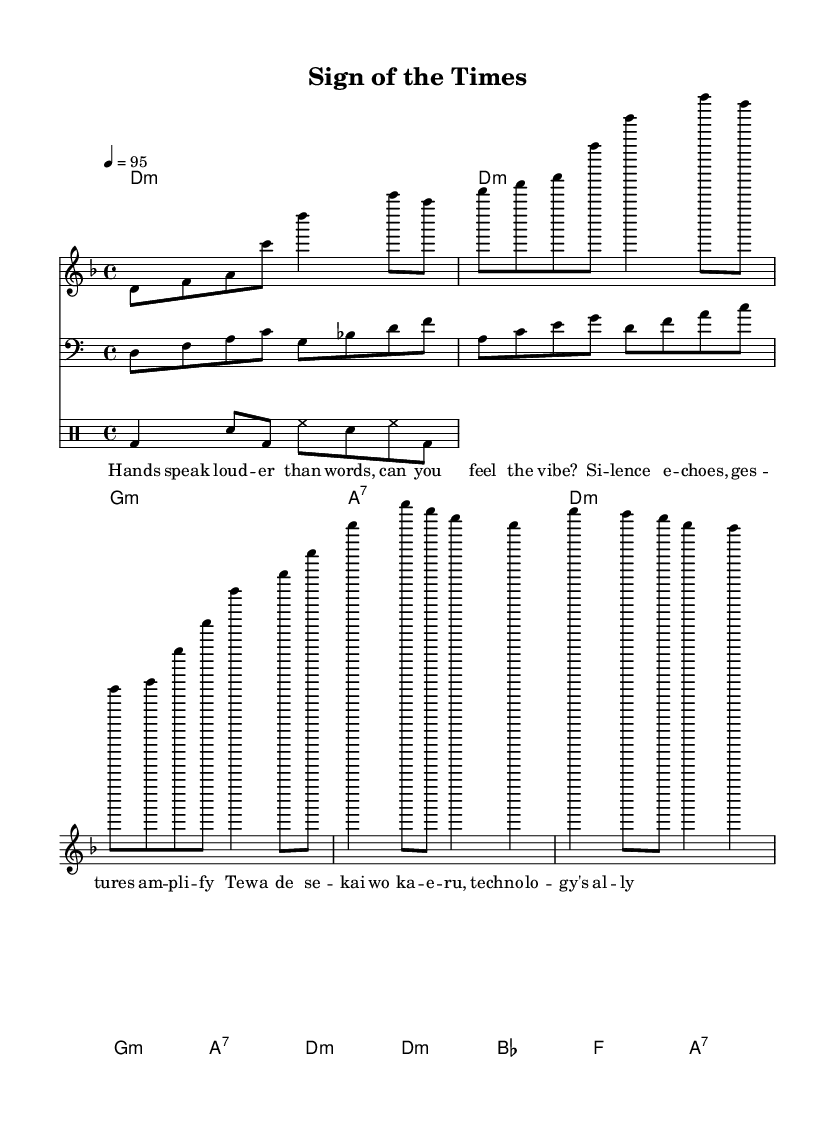What is the key signature of this music? The key signature is indicated as D minor, which typically includes one flat. In the staff, we see a flat sign associated with the D key.
Answer: D minor What is the time signature of this piece? The time signature is indicated at the beginning as 4/4, which means there are four beats in each measure and each beat is a quarter note. This can be identified from the notational symbols at the start of the sheet music.
Answer: 4/4 What is the tempo marking for this music? The tempo marking indicates that the piece should be played at a speed of 95 beats per minute, as shown in the notation. This is noted next to the tempo symbol in the sheet music.
Answer: 95 How many measures are in the verse section? The verse section consists of four measures, as we can count the measures from the notation where the verses are notated. These sections are visually segmented by the bar lines.
Answer: 4 Which instruments are included in this composition? The composition includes a melody staff, a bass line staff, and a drum staff. Identifying the different staves at the start of the score allows us to see what instrumentation is included.
Answer: Melody, Bass, Drums What kind of lyrical content is featured in this rap? The lyrics reflect themes of communication and technology, specifically emphasizing the power of gestures and sign language, which is expressed through wordplay with multilingual elements evident in the phrasing.
Answer: Communication, Technology How many chords are used in the chorus section? The chorus section consists of four chords: D minor, B flat, F, and A seventh, as indicated in the chord names. This can be determined by looking at the chord symbols written above the melody section.
Answer: 4 